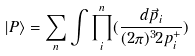<formula> <loc_0><loc_0><loc_500><loc_500>| P \rangle = \sum _ { n } \int \prod _ { i } ^ { n } ( \frac { d \vec { p } _ { i } } { ( 2 \pi ) ^ { 3 } 2 p _ { i } ^ { + } } )</formula> 